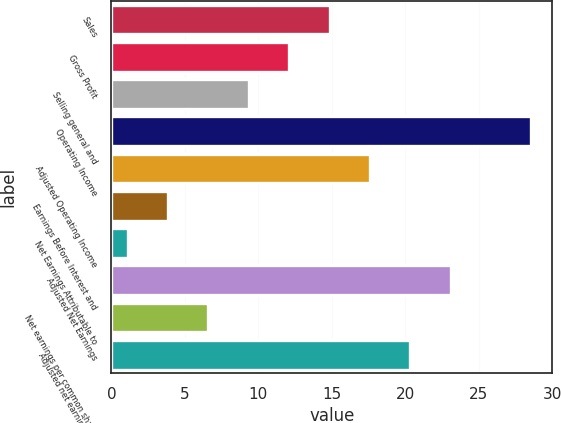Convert chart. <chart><loc_0><loc_0><loc_500><loc_500><bar_chart><fcel>Sales<fcel>Gross Profit<fcel>Selling general and<fcel>Operating Income<fcel>Adjusted Operating Income<fcel>Earnings Before Interest and<fcel>Net Earnings Attributable to<fcel>Adjusted Net Earnings<fcel>Net earnings per common share<fcel>Adjusted net earnings per<nl><fcel>14.85<fcel>12.1<fcel>9.35<fcel>28.6<fcel>17.6<fcel>3.85<fcel>1.1<fcel>23.1<fcel>6.6<fcel>20.35<nl></chart> 